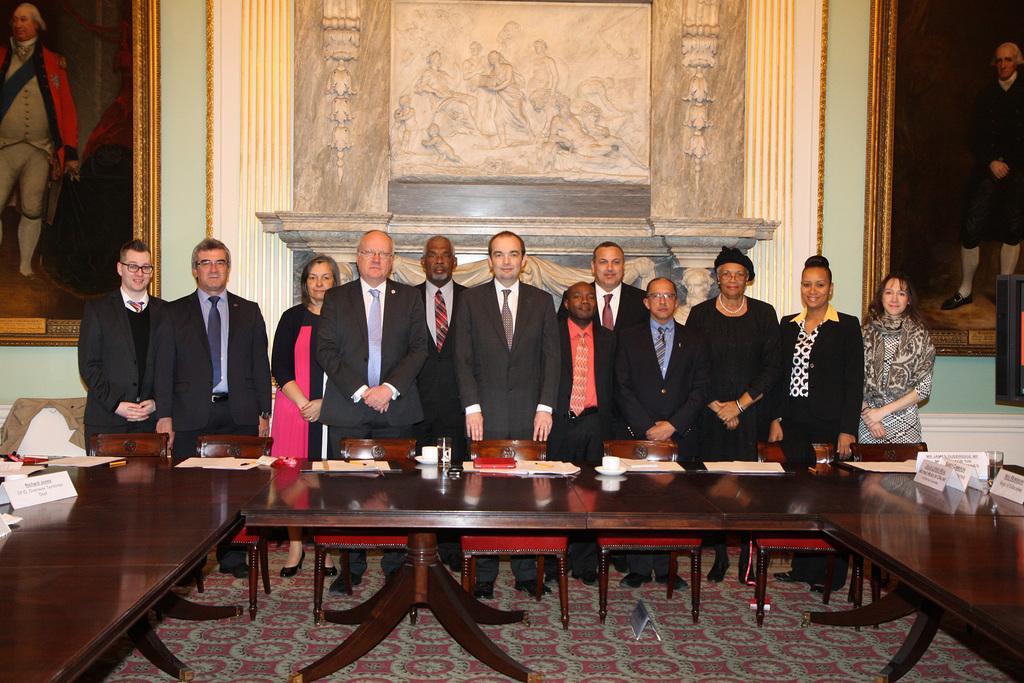Describe this image in one or two sentences. Group of people standing and we can see chairs and name boards, cups, saucers and some objects on table. On the background we can see frames on wall. 